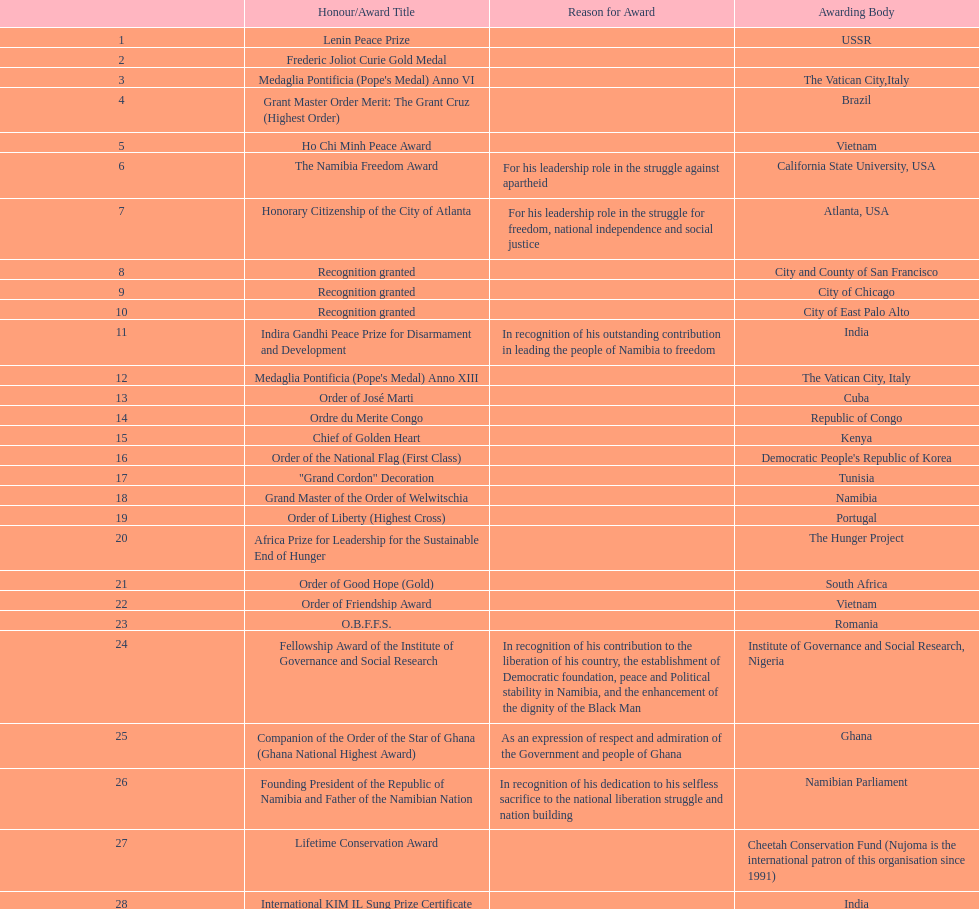According to this chart, how many total honors/award titles were mentioned? 29. 